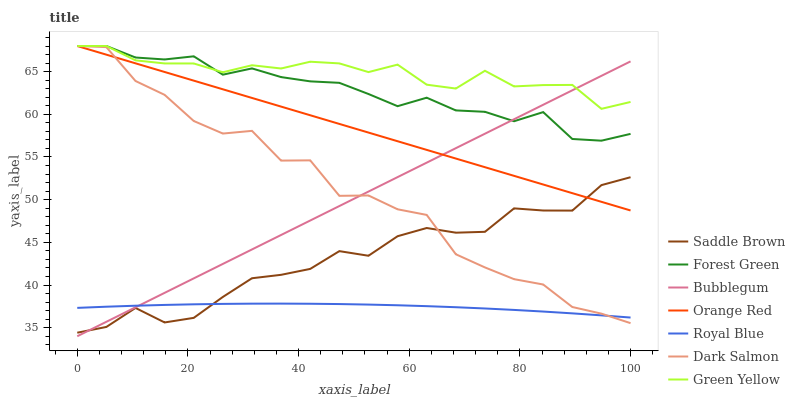Does Royal Blue have the minimum area under the curve?
Answer yes or no. Yes. Does Green Yellow have the maximum area under the curve?
Answer yes or no. Yes. Does Bubblegum have the minimum area under the curve?
Answer yes or no. No. Does Bubblegum have the maximum area under the curve?
Answer yes or no. No. Is Orange Red the smoothest?
Answer yes or no. Yes. Is Dark Salmon the roughest?
Answer yes or no. Yes. Is Bubblegum the smoothest?
Answer yes or no. No. Is Bubblegum the roughest?
Answer yes or no. No. Does Orange Red have the lowest value?
Answer yes or no. No. Does Green Yellow have the highest value?
Answer yes or no. Yes. Does Bubblegum have the highest value?
Answer yes or no. No. Is Royal Blue less than Green Yellow?
Answer yes or no. Yes. Is Green Yellow greater than Royal Blue?
Answer yes or no. Yes. Does Dark Salmon intersect Royal Blue?
Answer yes or no. Yes. Is Dark Salmon less than Royal Blue?
Answer yes or no. No. Is Dark Salmon greater than Royal Blue?
Answer yes or no. No. Does Royal Blue intersect Green Yellow?
Answer yes or no. No. 